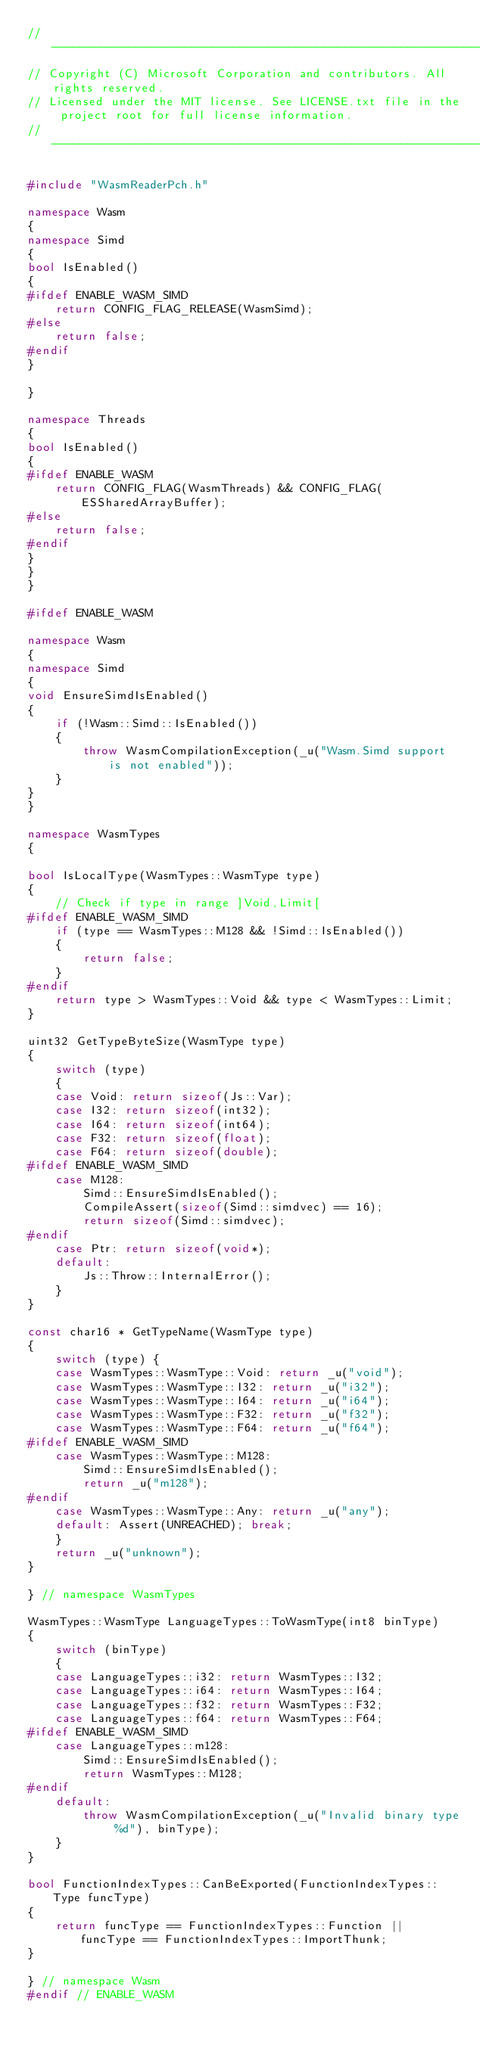Convert code to text. <code><loc_0><loc_0><loc_500><loc_500><_C++_>//-------------------------------------------------------------------------------------------------------
// Copyright (C) Microsoft Corporation and contributors. All rights reserved.
// Licensed under the MIT license. See LICENSE.txt file in the project root for full license information.
//-------------------------------------------------------------------------------------------------------

#include "WasmReaderPch.h"

namespace Wasm
{
namespace Simd
{
bool IsEnabled()
{
#ifdef ENABLE_WASM_SIMD
    return CONFIG_FLAG_RELEASE(WasmSimd);
#else
    return false;
#endif
}

}

namespace Threads
{
bool IsEnabled()
{
#ifdef ENABLE_WASM
    return CONFIG_FLAG(WasmThreads) && CONFIG_FLAG(ESSharedArrayBuffer);
#else
    return false;
#endif
}
}
}

#ifdef ENABLE_WASM

namespace Wasm
{
namespace Simd
{
void EnsureSimdIsEnabled()
{
    if (!Wasm::Simd::IsEnabled())
    {
        throw WasmCompilationException(_u("Wasm.Simd support is not enabled"));
    }
}
}

namespace WasmTypes
{

bool IsLocalType(WasmTypes::WasmType type)
{
    // Check if type in range ]Void,Limit[
#ifdef ENABLE_WASM_SIMD
    if (type == WasmTypes::M128 && !Simd::IsEnabled())
    {
        return false;
    }
#endif
    return type > WasmTypes::Void && type < WasmTypes::Limit;
}

uint32 GetTypeByteSize(WasmType type)
{
    switch (type)
    {
    case Void: return sizeof(Js::Var);
    case I32: return sizeof(int32);
    case I64: return sizeof(int64);
    case F32: return sizeof(float);
    case F64: return sizeof(double);
#ifdef ENABLE_WASM_SIMD
    case M128:
        Simd::EnsureSimdIsEnabled();
        CompileAssert(sizeof(Simd::simdvec) == 16);
        return sizeof(Simd::simdvec);
#endif
    case Ptr: return sizeof(void*);
    default:
        Js::Throw::InternalError();
    }
}

const char16 * GetTypeName(WasmType type)
{
    switch (type) {
    case WasmTypes::WasmType::Void: return _u("void");
    case WasmTypes::WasmType::I32: return _u("i32");
    case WasmTypes::WasmType::I64: return _u("i64");
    case WasmTypes::WasmType::F32: return _u("f32");
    case WasmTypes::WasmType::F64: return _u("f64");
#ifdef ENABLE_WASM_SIMD
    case WasmTypes::WasmType::M128: 
        Simd::EnsureSimdIsEnabled();
        return _u("m128");
#endif
    case WasmTypes::WasmType::Any: return _u("any");
    default: Assert(UNREACHED); break;
    }
    return _u("unknown");
}

} // namespace WasmTypes

WasmTypes::WasmType LanguageTypes::ToWasmType(int8 binType)
{
    switch (binType)
    {
    case LanguageTypes::i32: return WasmTypes::I32;
    case LanguageTypes::i64: return WasmTypes::I64;
    case LanguageTypes::f32: return WasmTypes::F32;
    case LanguageTypes::f64: return WasmTypes::F64;
#ifdef ENABLE_WASM_SIMD
    case LanguageTypes::m128:
        Simd::EnsureSimdIsEnabled();
        return WasmTypes::M128;
#endif
    default:
        throw WasmCompilationException(_u("Invalid binary type %d"), binType);
    }
}

bool FunctionIndexTypes::CanBeExported(FunctionIndexTypes::Type funcType)
{
    return funcType == FunctionIndexTypes::Function || funcType == FunctionIndexTypes::ImportThunk;
}

} // namespace Wasm
#endif // ENABLE_WASM
</code> 